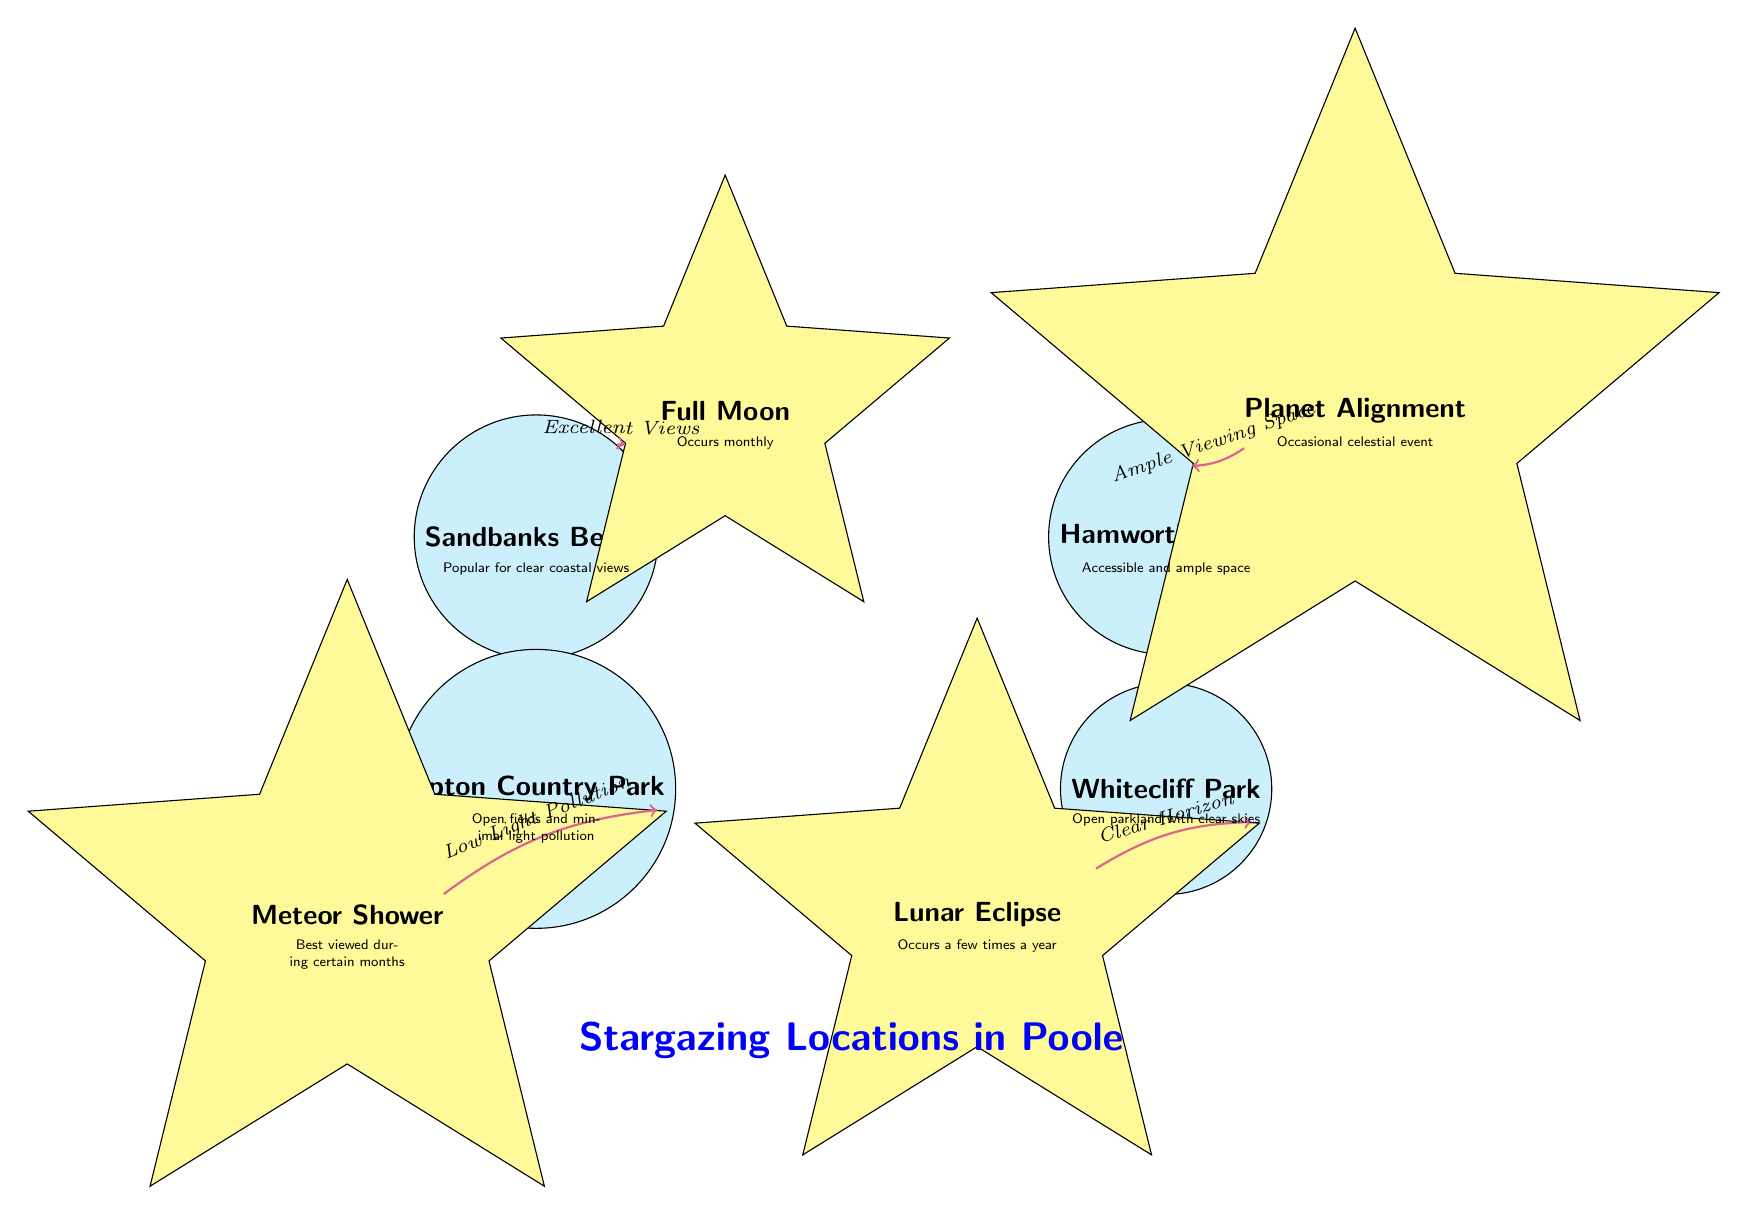What are the four stargazing locations mentioned in the diagram? The diagram lists Sandbanks Beach, Upton Country Park, Hamworthy Park, and Whitecliff Park as the four stargazing locations.
Answer: Sandbanks Beach, Upton Country Park, Hamworthy Park, Whitecliff Park Which location is noted for having low light pollution? Upton Country Park is identified in the diagram as having low light pollution, making it suitable for meteor shower viewing.
Answer: Upton Country Park How many celestial events are shown in the diagram? The diagram displays a total of four celestial events: Full Moon, Meteor Shower, Planet Alignment, and Lunar Eclipse.
Answer: 4 Which event is best viewed from Sandbanks Beach? The diagram indicates that the Full Moon is best viewed from Sandbanks Beach, due to its excellent views.
Answer: Full Moon What is the primary feature that makes Hamworthy Park suitable for planet alignment viewing? The diagram highlights that Hamworthy Park offers ample viewing space, making it a suitable location for planet alignment viewing.
Answer: Ample Viewing Space What type of celestial event occurs monthly according to the diagram? The Full Moon is an event in the diagram that occurs monthly, as stated in the description associated with it.
Answer: Full Moon Which stargazing location is described as having open parkland with clear skies? The diagram describes Whitecliff Park as an area with open parkland and clear skies, making it suitable for viewing a lunar eclipse.
Answer: Whitecliff Park Which celestial event has the least frequency as mentioned in the diagram? The diagram states that the Planet Alignment is an occasional celestial event, indicating that it doesn't occur frequently compared to others listed.
Answer: Occasional celestial event 